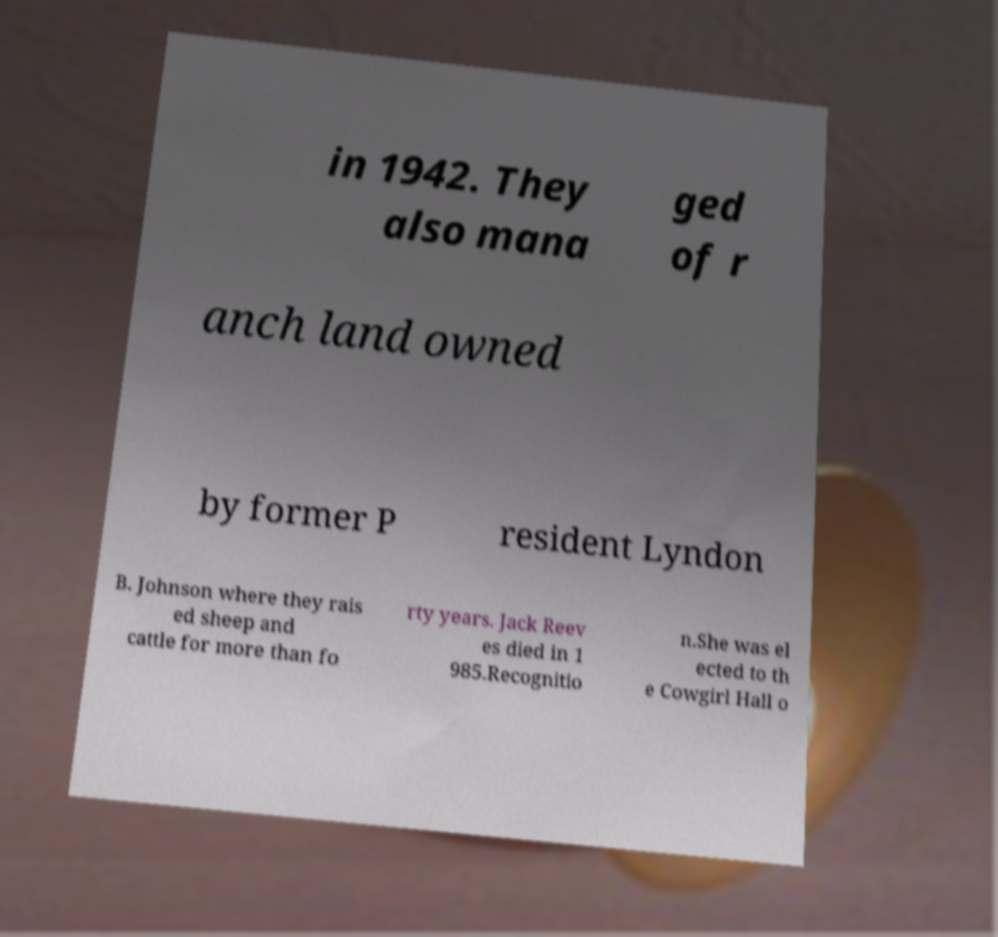Could you assist in decoding the text presented in this image and type it out clearly? in 1942. They also mana ged of r anch land owned by former P resident Lyndon B. Johnson where they rais ed sheep and cattle for more than fo rty years. Jack Reev es died in 1 985.Recognitio n.She was el ected to th e Cowgirl Hall o 